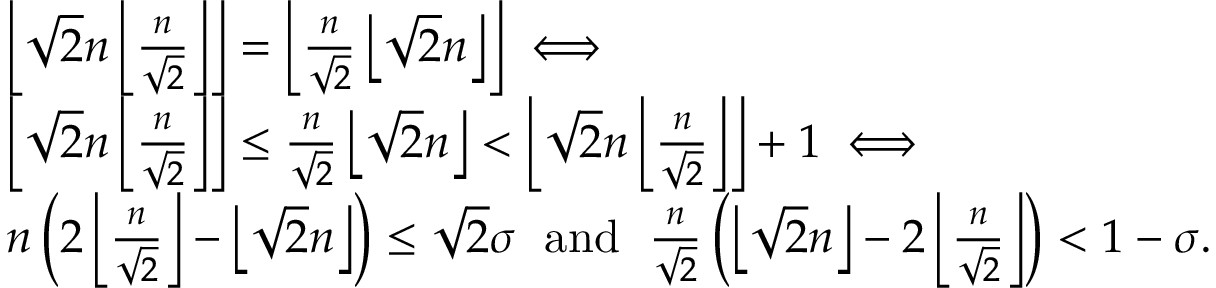Convert formula to latex. <formula><loc_0><loc_0><loc_500><loc_500>\begin{array} { r l } & { \left \lfloor \sqrt { 2 } n \left \lfloor \frac { n } { \sqrt { 2 } } \right \rfloor \right \rfloor = \left \lfloor \frac { n } { \sqrt { 2 } } \left \lfloor \sqrt { 2 } n \right \rfloor \right \rfloor \iff } \\ & { \left \lfloor \sqrt { 2 } n \left \lfloor \frac { n } { \sqrt { 2 } } \right \rfloor \right \rfloor \leq \frac { n } { \sqrt { 2 } } \left \lfloor \sqrt { 2 } n \right \rfloor < \left \lfloor \sqrt { 2 } n \left \lfloor \frac { n } { \sqrt { 2 } } \right \rfloor \right \rfloor + 1 \iff } \\ & { n \left ( 2 \left \lfloor \frac { n } { \sqrt { 2 } } \right \rfloor - \left \lfloor \sqrt { 2 } n \right \rfloor \right ) \leq \sqrt { 2 } \sigma \, a n d \, \frac { n } { \sqrt { 2 } } \left ( \left \lfloor \sqrt { 2 } n \right \rfloor - 2 \left \lfloor \frac { n } { \sqrt { 2 } } \right \rfloor \right ) < 1 - \sigma . } \end{array}</formula> 